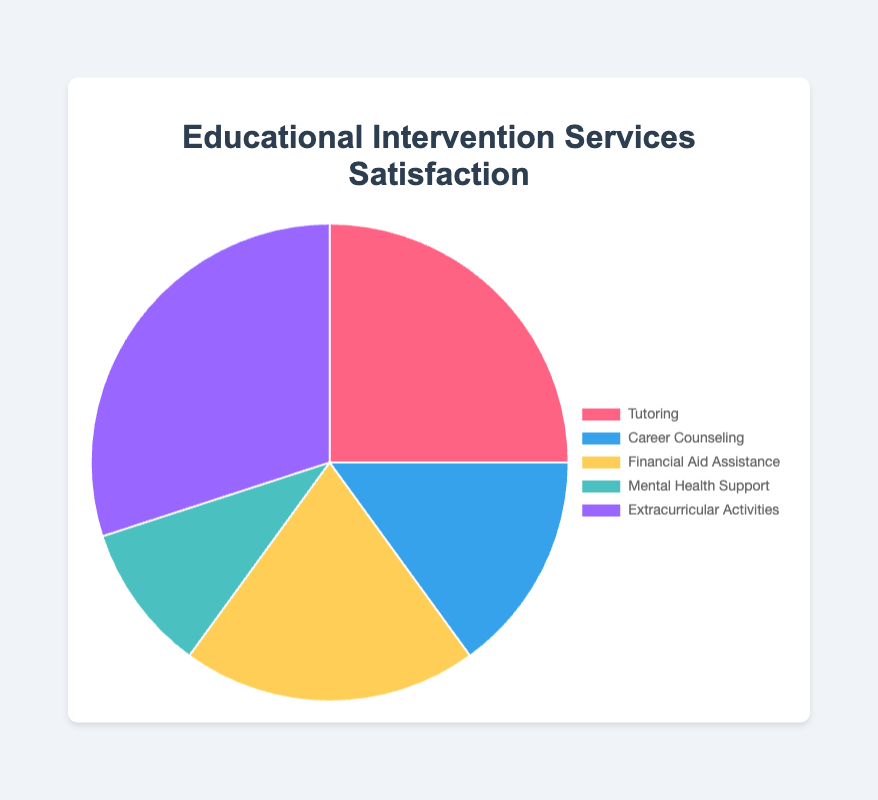What percentage of participants were satisfied with Financial Aid Assistance? Identify the segment labeled "Financial Aid Assistance" in the pie chart. The percentage associated with it is 20%.
Answer: 20% Which service received the highest satisfaction rate? Locate the largest segment in the pie chart. The segment labeled "Extracurricular Activities" is the largest one, indicating it has the highest satisfaction rate at 30%.
Answer: Extracurricular Activities How much higher is the satisfaction rate for Tutoring compared to Mental Health Support? Find the segments labeled "Tutoring" and "Mental Health Support". The satisfaction rates are 25% and 10%, respectively. Subtract the rate of Mental Health Support from Tutoring: 25% - 10% = 15%.
Answer: 15% What is the combined satisfaction rate for Career Counseling and Mental Health Support? Locate the segments for "Career Counseling" and "Mental Health Support". The rates are 15% and 10%, respectively. Add these values: 15% + 10% = 25%.
Answer: 25% Which two services have an equal gap of 10% between them? Review the satisfaction rates for all services: Tutoring (25%), Career Counseling (15%), Financial Aid Assistance (20%), Mental Health Support (10%), and Extracurricular Activities (30%). Subtract the rates pairwise to find the difference. Tutoring and Financial Aid Assistance have a 5% difference, Financial Aid Assistance and Extracurricular Activities have a 10% difference, Mental Health Support and Career Counseling have a 5% difference, etc.
Answer: Financial Aid Assistance and Extracurricular Activities What color represents Career Counseling on the chart? Identify the segment labeled "Career Counseling". It is shown with the color "blue".
Answer: blue What is the average satisfaction rate for all the services? To find the average, sum up the satisfaction rates for all services and divide by the number of services: (25% + 15% + 20% + 10% + 30%) / 5 = 20%.
Answer: 20% Which service has the second smallest satisfaction rate? Examine the segments to find the smallest and second smallest percentages. The smallest is Mental Health Support at 10%, and the second smallest is Career Counseling at 15%.
Answer: Career Counseling What is the difference in satisfaction rates between the highest and lowest-rated services? Identify the highest and lowest satisfaction rates: Extracurricular Activities (30%) and Mental Health Support (10%). Subtract the lowest from the highest: 30% - 10% = 20%.
Answer: 20% 